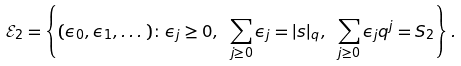<formula> <loc_0><loc_0><loc_500><loc_500>\mathcal { E } _ { 2 } = \left \{ ( \epsilon _ { 0 } , \epsilon _ { 1 } , \dots ) \colon \epsilon _ { j } \geq 0 , \ \sum _ { j \geq 0 } \epsilon _ { j } = | s | _ { q } , \ \sum _ { j \geq 0 } \epsilon _ { j } q ^ { j } = S _ { 2 } \right \} .</formula> 